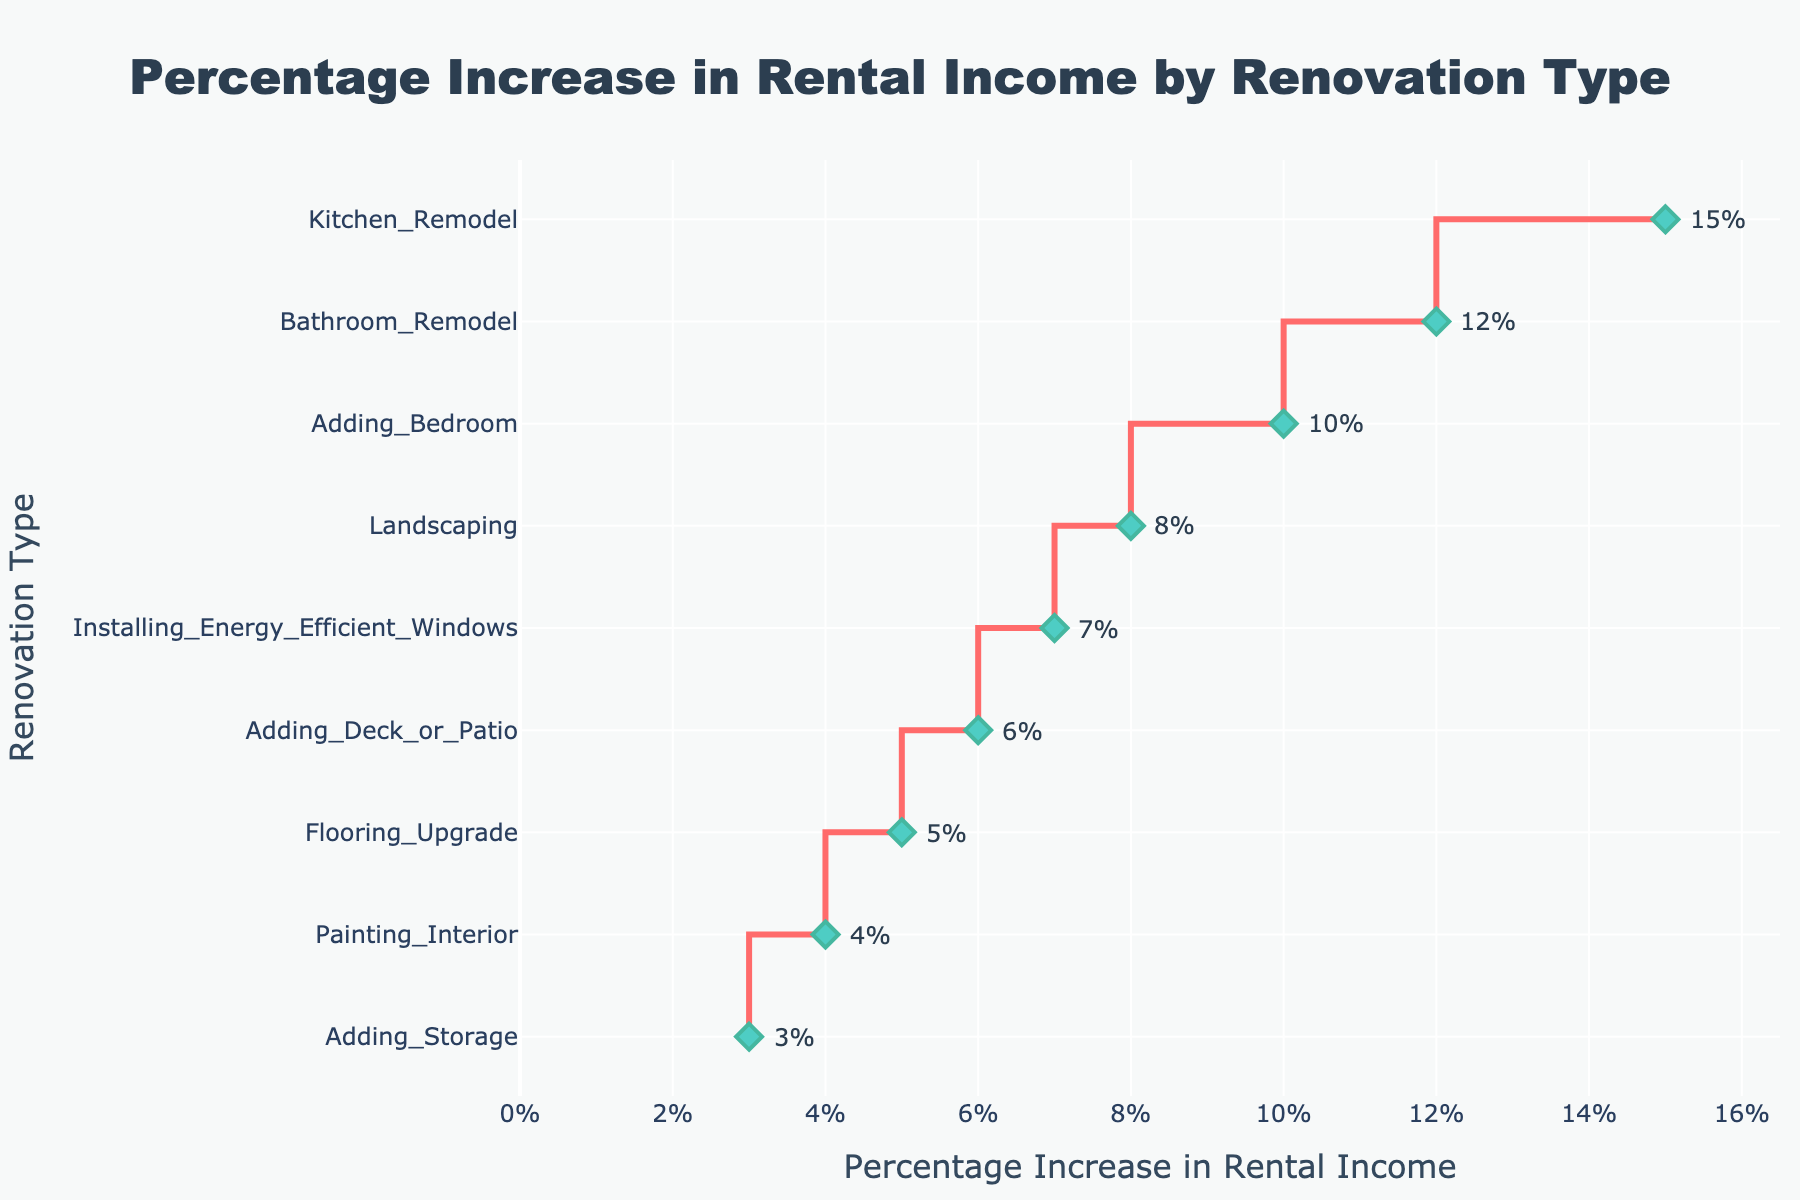What's the title of the figure? The title is typically displayed at the top of the figure, providing a succinct description of what the plot represents. Here, it is given as part of the figure's layout.
Answer: Percentage Increase in Rental Income by Renovation Type What is the highest percentage increase in rental income and which renovation type does it correspond to? Locate the point with the highest x-value on the plot. The corresponding y-value will indicate the renovation type.
Answer: 15%, Kitchen Remodel Which renovation type results in the smallest percentage increase in rental income? Look for the point with the smallest x-value and note the corresponding y-value, which represents the renovation type.
Answer: Adding Storage How much higher is the percentage increase in rental income for a Kitchen Remodel compared to Adding Storage? Find the percentage increase for Kitchen Remodel and Adding Storage and subtract the latter from the former: 15% - 3% = 12%.
Answer: 12% What is the median percentage increase in rental income among all renovation types? List all percentages: 15, 12, 10, 8, 7, 6, 5, 4, 3. The median is the middle value in the sorted list: 8% (it is the 5th value when sorted).
Answer: 8% Which two renovation types have the closest percentage increases? Compare the differences between adjacent percentages in the sorted list, find the smallest difference: Adding Storage (3%) and Painting Interior (4%) have a difference of 1%.
Answer: Painting Interior and Adding Storage What is the average percentage increase in rental income for all renovation types? Sum all percentages and divide by the number of renovation types: (15 + 12 + 10 + 8 + 7 + 6 + 5 + 4 + 3) / 9 = 7.78%.
Answer: 7.78% By how much does the percentage increase in rental income for Bathroom Remodel differ from that of Installing Energy Efficient Windows? Subtract the percentage for Installing Energy Efficient Windows from Bathroom Remodel: 12% - 7% = 5%.
Answer: 5% Which renovation type provides exactly twice the percentage increase in rental income as Flooring Upgrade? Identify the percentage for Flooring Upgrade (5%) and look for a renovation type with 2 * 5% = 10%: Adding Bedroom matches.
Answer: Adding Bedroom Between Landscaping and Adding a Deck or Patio, which one provides a higher increase in rental income? Compare the percentages for Landscaping (8%) and Adding Deck or Patio (6%): Landscaping is higher.
Answer: Landscaping 